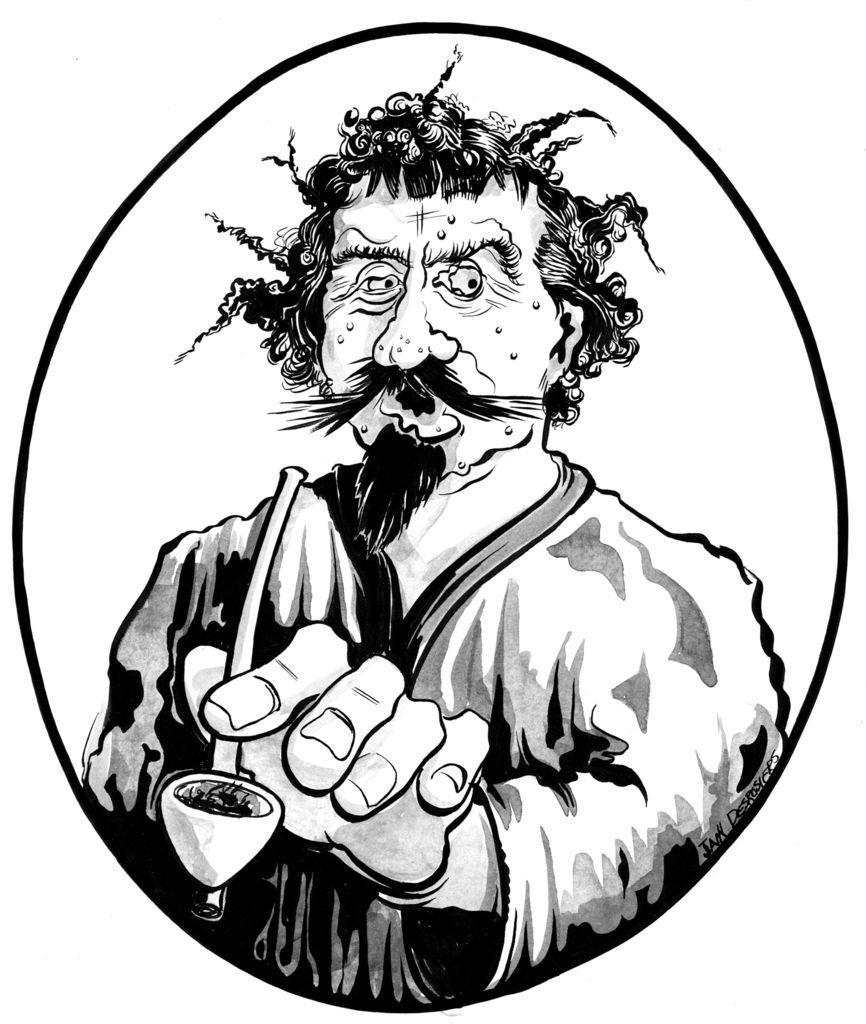How would you summarize this image in a sentence or two? In this picture we can see a sketch of a person, there is a white color background. 